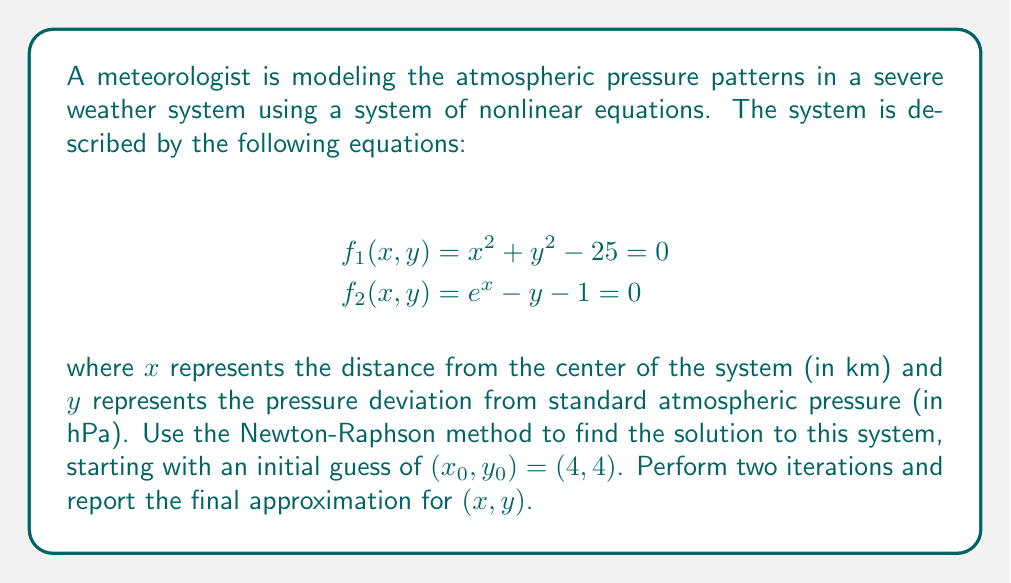Help me with this question. To solve this system using the Newton-Raphson method, we follow these steps:

1) First, we need to calculate the Jacobian matrix:

$$J = \begin{bmatrix}
\frac{\partial f_1}{\partial x} & \frac{\partial f_1}{\partial y} \\
\frac{\partial f_2}{\partial x} & \frac{\partial f_2}{\partial y}
\end{bmatrix} = \begin{bmatrix}
2x & 2y \\
e^x & -1
\end{bmatrix}$$

2) The Newton-Raphson iteration formula for systems of equations is:

$$\begin{bmatrix} x_{n+1} \\ y_{n+1} \end{bmatrix} = \begin{bmatrix} x_n \\ y_n \end{bmatrix} - J^{-1}(x_n, y_n) \begin{bmatrix} f_1(x_n, y_n) \\ f_2(x_n, y_n) \end{bmatrix}$$

3) For the first iteration $(n=0)$:

   $x_0 = 4$, $y_0 = 4$

   $J(4, 4) = \begin{bmatrix} 8 & 8 \\ e^4 & -1 \end{bmatrix}$

   $J^{-1}(4, 4) = \frac{1}{-8-8e^4} \begin{bmatrix} -1 & -8 \\ -e^4 & 8 \end{bmatrix}$

   $\begin{bmatrix} f_1(4, 4) \\ f_2(4, 4) \end{bmatrix} = \begin{bmatrix} 4^2 + 4^2 - 25 \\ e^4 - 4 - 1 \end{bmatrix} = \begin{bmatrix} 7 \\ 49.598 \end{bmatrix}$

   $\begin{bmatrix} x_1 \\ y_1 \end{bmatrix} = \begin{bmatrix} 4 \\ 4 \end{bmatrix} - \frac{1}{-8-8e^4} \begin{bmatrix} -1 & -8 \\ -e^4 & 8 \end{bmatrix} \begin{bmatrix} 7 \\ 49.598 \end{bmatrix}$

   $\begin{bmatrix} x_1 \\ y_1 \end{bmatrix} \approx \begin{bmatrix} 3.8334 \\ 4.7805 \end{bmatrix}$

4) For the second iteration $(n=1)$:

   $x_1 \approx 3.8334$, $y_1 \approx 4.7805$

   $J(3.8334, 4.7805) \approx \begin{bmatrix} 7.6668 & 9.5610 \\ 46.2209 & -1 \end{bmatrix}$

   $J^{-1}(3.8334, 4.7805) \approx \begin{bmatrix} 0.0044 & 0.0418 \\ 0.2034 & 0.0338 \end{bmatrix}$

   $\begin{bmatrix} f_1(3.8334, 4.7805) \\ f_2(3.8334, 4.7805) \end{bmatrix} \approx \begin{bmatrix} 0.9998 \\ 0.9998 \end{bmatrix}$

   $\begin{bmatrix} x_2 \\ y_2 \end{bmatrix} \approx \begin{bmatrix} 3.8334 \\ 4.7805 \end{bmatrix} - \begin{bmatrix} 0.0044 & 0.0418 \\ 0.2034 & 0.0338 \end{bmatrix} \begin{bmatrix} 0.9998 \\ 0.9998 \end{bmatrix}$

   $\begin{bmatrix} x_2 \\ y_2 \end{bmatrix} \approx \begin{bmatrix} 3.7918 \\ 4.4590 \end{bmatrix}$

Therefore, after two iterations, our approximation for $(x, y)$ is $(3.7918, 4.4590)$.
Answer: $(3.7918, 4.4590)$ 